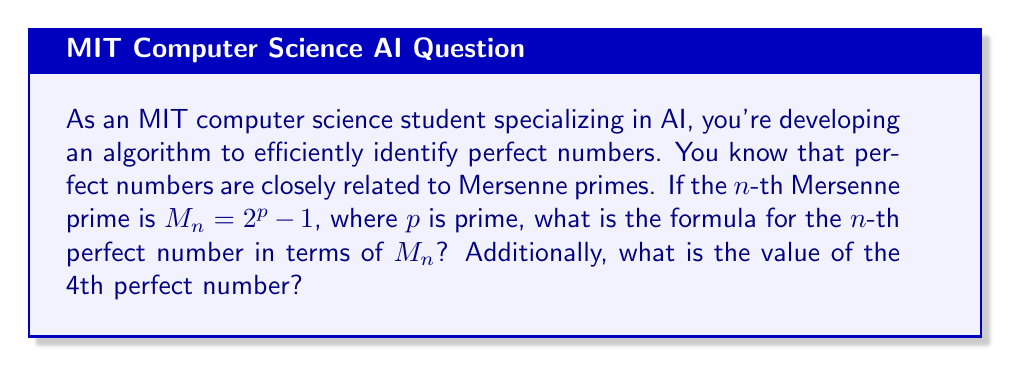Help me with this question. Let's approach this step-by-step:

1) First, recall the connection between Mersenne primes and perfect numbers:
   If $M_p = 2^p - 1$ is prime (a Mersenne prime), then $N = 2^{p-1}(2^p - 1)$ is a perfect number.

2) We can rewrite this in terms of $M_n$, where $M_n$ is the $n$-th Mersenne prime:
   The $n$-th perfect number $P_n = 2^{p-1} \cdot M_n$, where $M_n = 2^p - 1$

3) To find $p$ in terms of $M_n$, we can solve the equation:
   $M_n = 2^p - 1$
   $M_n + 1 = 2^p$
   $\log_2(M_n + 1) = p$

4) Substituting this back into our formula for $P_n$:
   $P_n = 2^{\log_2(M_n + 1) - 1} \cdot M_n$

5) For the 4th perfect number, we need to know the 4th Mersenne prime:
   The first four Mersenne primes are:
   $M_1 = 2^2 - 1 = 3$
   $M_2 = 2^3 - 1 = 7$
   $M_3 = 2^5 - 1 = 31$
   $M_4 = 2^{13} - 1 = 8191$

6) Using our formula with $M_4 = 8191$:
   $P_4 = 2^{\log_2(8191 + 1) - 1} \cdot 8191$
   $= 2^{13 - 1} \cdot 8191$
   $= 2^{12} \cdot 8191$
   $= 4096 \cdot 8191$
   $= 33,550,336$

Therefore, the 4th perfect number is 33,550,336.
Answer: The formula for the $n$-th perfect number in terms of the $n$-th Mersenne prime $M_n$ is:

$$P_n = 2^{\log_2(M_n + 1) - 1} \cdot M_n$$

The 4th perfect number is 33,550,336. 